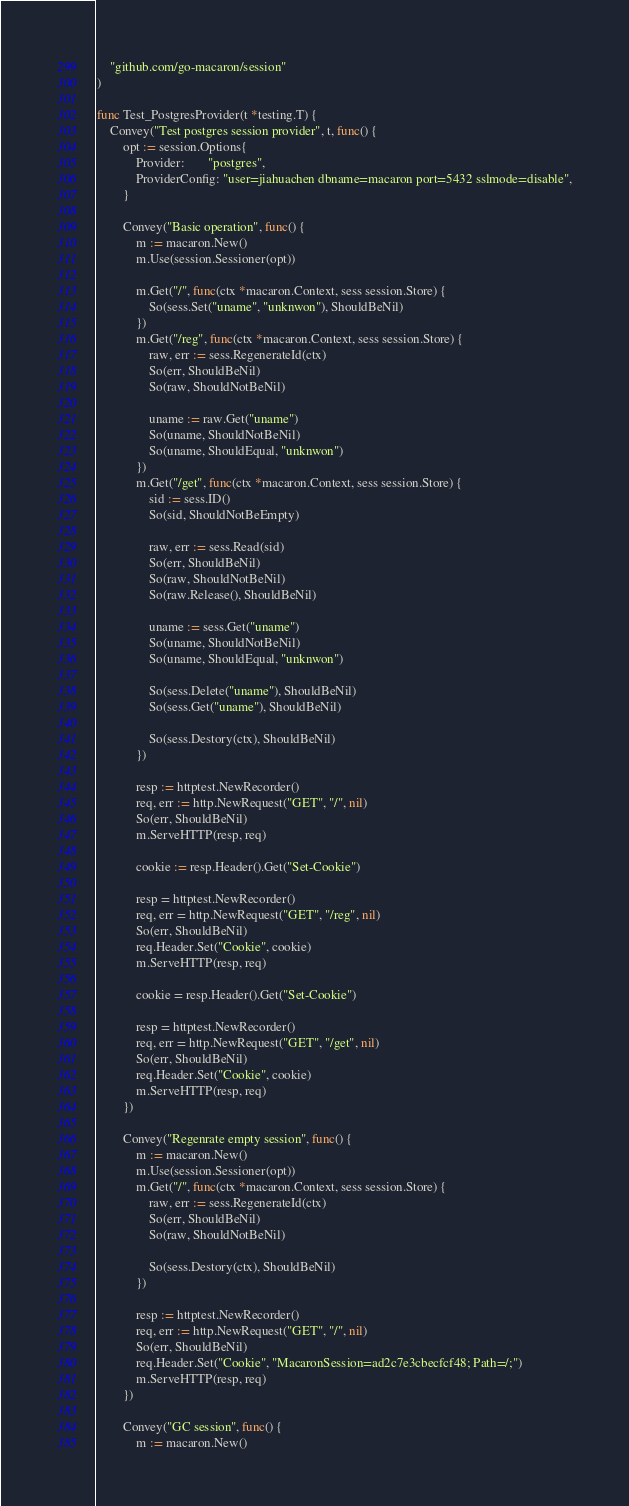Convert code to text. <code><loc_0><loc_0><loc_500><loc_500><_Go_>
	"github.com/go-macaron/session"
)

func Test_PostgresProvider(t *testing.T) {
	Convey("Test postgres session provider", t, func() {
		opt := session.Options{
			Provider:       "postgres",
			ProviderConfig: "user=jiahuachen dbname=macaron port=5432 sslmode=disable",
		}

		Convey("Basic operation", func() {
			m := macaron.New()
			m.Use(session.Sessioner(opt))

			m.Get("/", func(ctx *macaron.Context, sess session.Store) {
				So(sess.Set("uname", "unknwon"), ShouldBeNil)
			})
			m.Get("/reg", func(ctx *macaron.Context, sess session.Store) {
				raw, err := sess.RegenerateId(ctx)
				So(err, ShouldBeNil)
				So(raw, ShouldNotBeNil)

				uname := raw.Get("uname")
				So(uname, ShouldNotBeNil)
				So(uname, ShouldEqual, "unknwon")
			})
			m.Get("/get", func(ctx *macaron.Context, sess session.Store) {
				sid := sess.ID()
				So(sid, ShouldNotBeEmpty)

				raw, err := sess.Read(sid)
				So(err, ShouldBeNil)
				So(raw, ShouldNotBeNil)
				So(raw.Release(), ShouldBeNil)

				uname := sess.Get("uname")
				So(uname, ShouldNotBeNil)
				So(uname, ShouldEqual, "unknwon")

				So(sess.Delete("uname"), ShouldBeNil)
				So(sess.Get("uname"), ShouldBeNil)

				So(sess.Destory(ctx), ShouldBeNil)
			})

			resp := httptest.NewRecorder()
			req, err := http.NewRequest("GET", "/", nil)
			So(err, ShouldBeNil)
			m.ServeHTTP(resp, req)

			cookie := resp.Header().Get("Set-Cookie")

			resp = httptest.NewRecorder()
			req, err = http.NewRequest("GET", "/reg", nil)
			So(err, ShouldBeNil)
			req.Header.Set("Cookie", cookie)
			m.ServeHTTP(resp, req)

			cookie = resp.Header().Get("Set-Cookie")

			resp = httptest.NewRecorder()
			req, err = http.NewRequest("GET", "/get", nil)
			So(err, ShouldBeNil)
			req.Header.Set("Cookie", cookie)
			m.ServeHTTP(resp, req)
		})

		Convey("Regenrate empty session", func() {
			m := macaron.New()
			m.Use(session.Sessioner(opt))
			m.Get("/", func(ctx *macaron.Context, sess session.Store) {
				raw, err := sess.RegenerateId(ctx)
				So(err, ShouldBeNil)
				So(raw, ShouldNotBeNil)

				So(sess.Destory(ctx), ShouldBeNil)
			})

			resp := httptest.NewRecorder()
			req, err := http.NewRequest("GET", "/", nil)
			So(err, ShouldBeNil)
			req.Header.Set("Cookie", "MacaronSession=ad2c7e3cbecfcf48; Path=/;")
			m.ServeHTTP(resp, req)
		})

		Convey("GC session", func() {
			m := macaron.New()</code> 